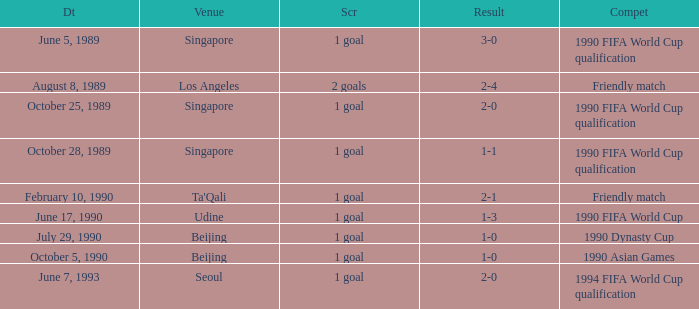What was the venue where the result was 2-1? Ta'Qali. 